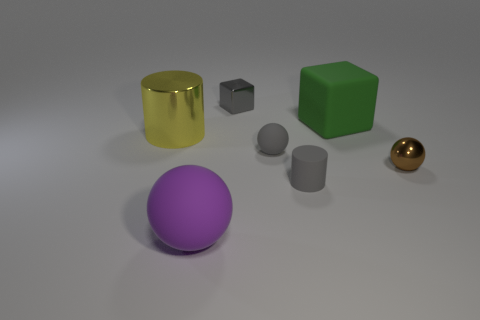Subtract all matte balls. How many balls are left? 1 Add 3 tiny green objects. How many objects exist? 10 Subtract all cyan balls. Subtract all purple blocks. How many balls are left? 3 Subtract all cylinders. How many objects are left? 5 Subtract all tiny gray shiny blocks. Subtract all big yellow cylinders. How many objects are left? 5 Add 5 purple rubber objects. How many purple rubber objects are left? 6 Add 1 gray shiny cubes. How many gray shiny cubes exist? 2 Subtract 1 purple balls. How many objects are left? 6 